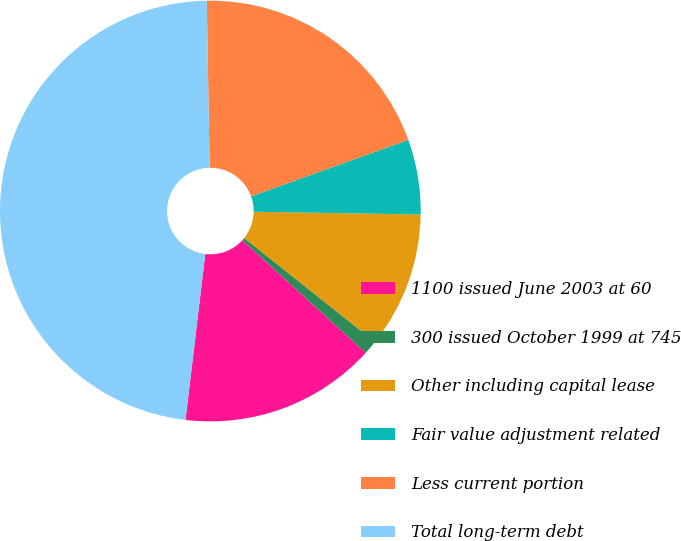<chart> <loc_0><loc_0><loc_500><loc_500><pie_chart><fcel>1100 issued June 2003 at 60<fcel>300 issued October 1999 at 745<fcel>Other including capital lease<fcel>Fair value adjustment related<fcel>Less current portion<fcel>Total long-term debt<nl><fcel>15.11%<fcel>1.08%<fcel>10.43%<fcel>5.75%<fcel>19.78%<fcel>47.84%<nl></chart> 